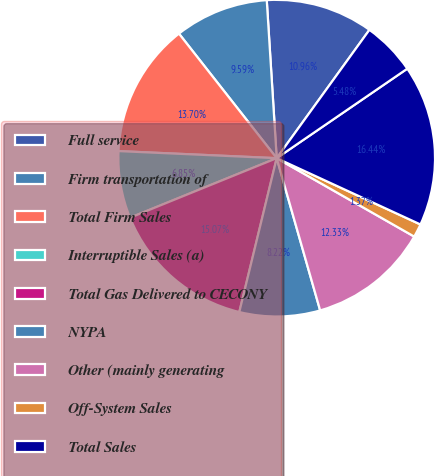Convert chart. <chart><loc_0><loc_0><loc_500><loc_500><pie_chart><fcel>Full service<fcel>Firm transportation of<fcel>Total Firm Sales<fcel>Interruptible Sales (a)<fcel>Total Gas Delivered to CECONY<fcel>NYPA<fcel>Other (mainly generating<fcel>Off-System Sales<fcel>Total Sales<fcel>Interruptible Sales<nl><fcel>10.96%<fcel>9.59%<fcel>13.7%<fcel>6.85%<fcel>15.07%<fcel>8.22%<fcel>12.33%<fcel>1.37%<fcel>16.44%<fcel>5.48%<nl></chart> 